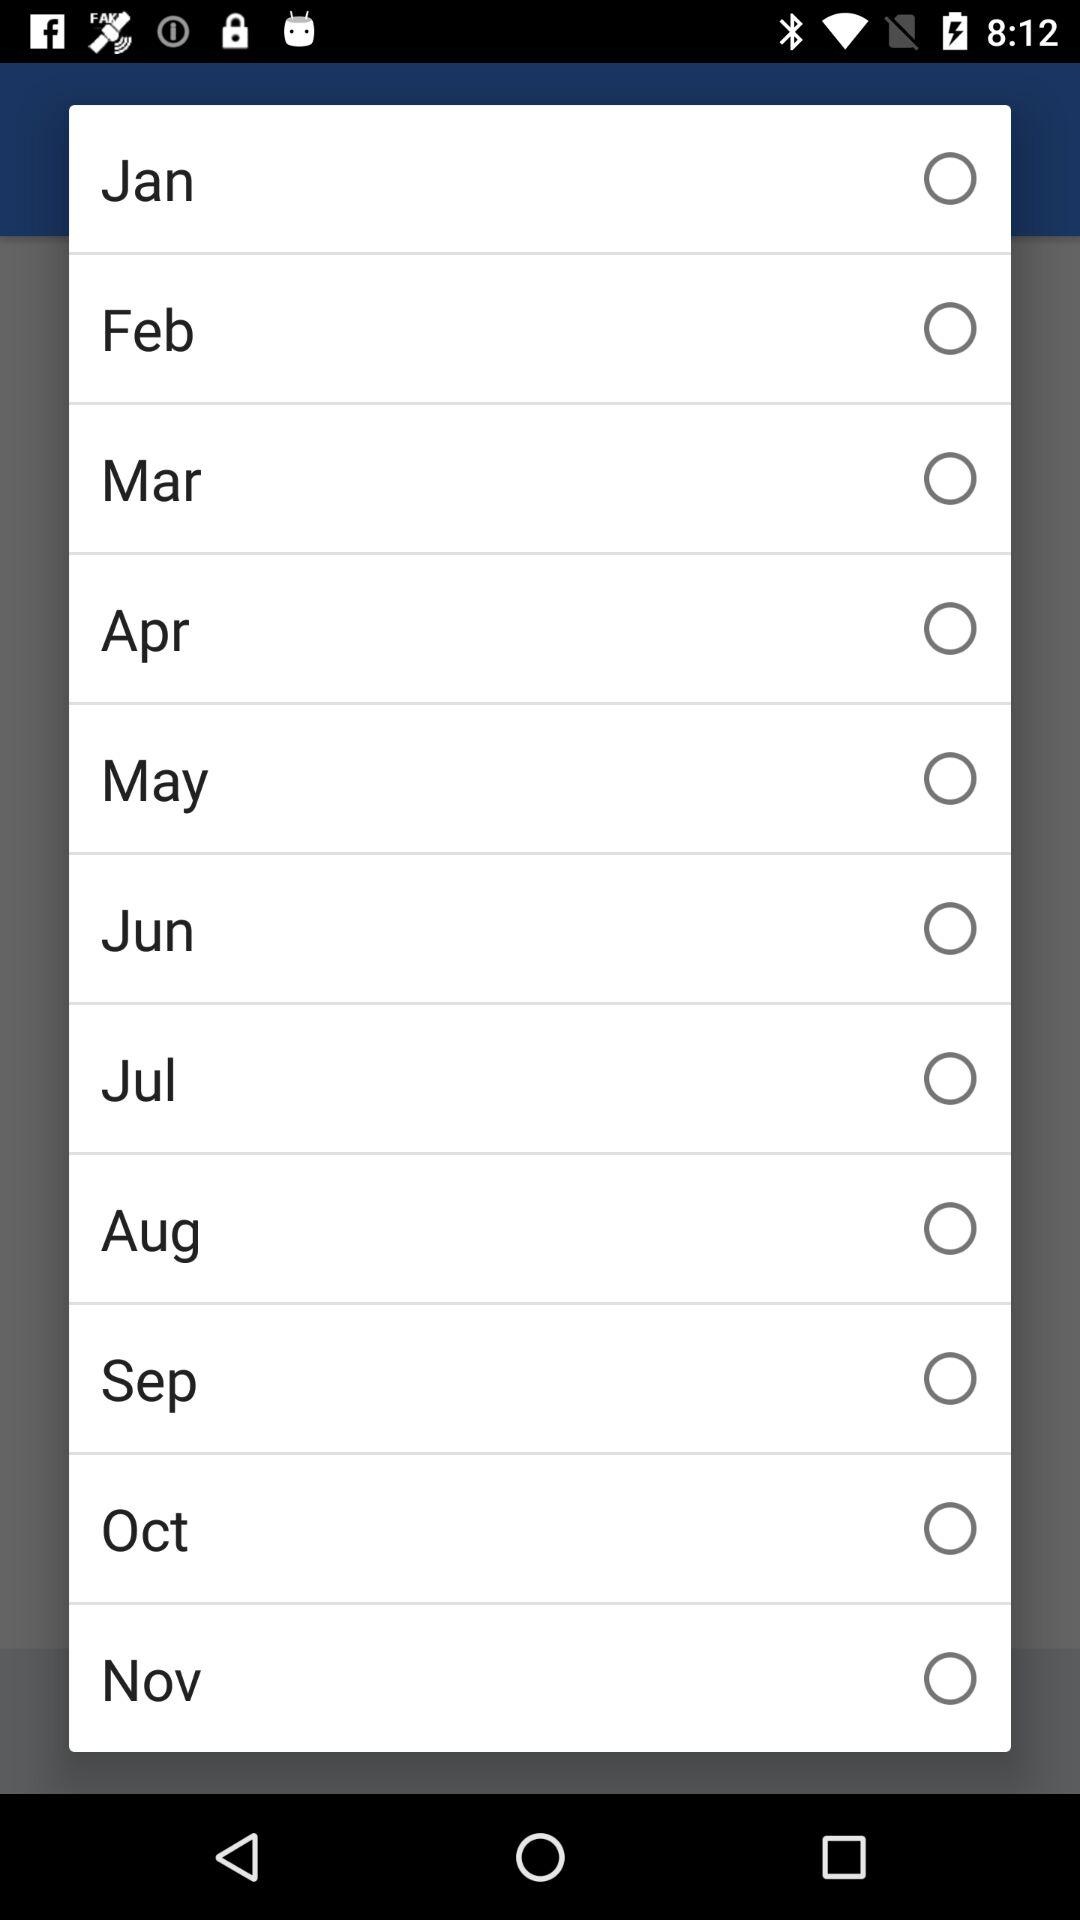What are the various names of the months? The various names of the months are January, February, March, April, May, June, July, August, September, October, and November. 